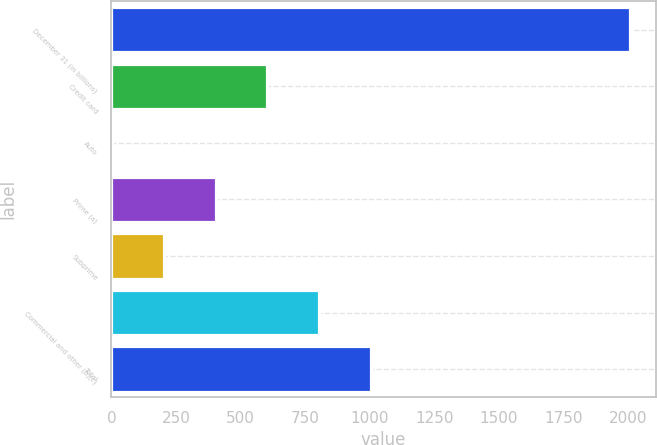Convert chart to OTSL. <chart><loc_0><loc_0><loc_500><loc_500><bar_chart><fcel>December 31 (in billions)<fcel>Credit card<fcel>Auto<fcel>Prime (a)<fcel>Subprime<fcel>Commercial and other (b)(c)<fcel>Total<nl><fcel>2007<fcel>603.71<fcel>2.3<fcel>403.24<fcel>202.77<fcel>804.18<fcel>1004.65<nl></chart> 